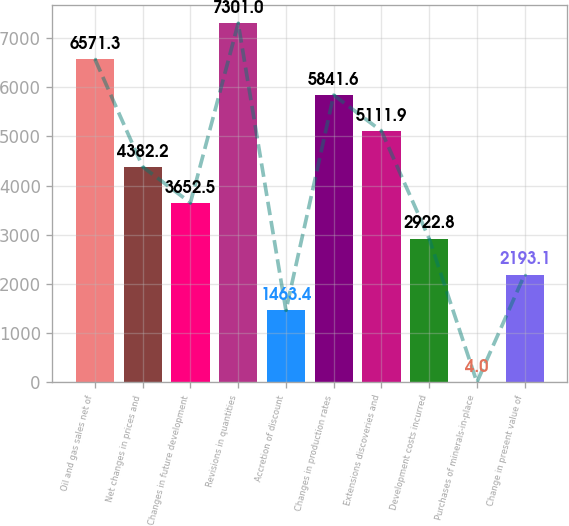Convert chart. <chart><loc_0><loc_0><loc_500><loc_500><bar_chart><fcel>Oil and gas sales net of<fcel>Net changes in prices and<fcel>Changes in future development<fcel>Revisions in quantities<fcel>Accretion of discount<fcel>Changes in production rates<fcel>Extensions discoveries and<fcel>Development costs incurred<fcel>Purchases of minerals-in-place<fcel>Change in present value of<nl><fcel>6571.3<fcel>4382.2<fcel>3652.5<fcel>7301<fcel>1463.4<fcel>5841.6<fcel>5111.9<fcel>2922.8<fcel>4<fcel>2193.1<nl></chart> 